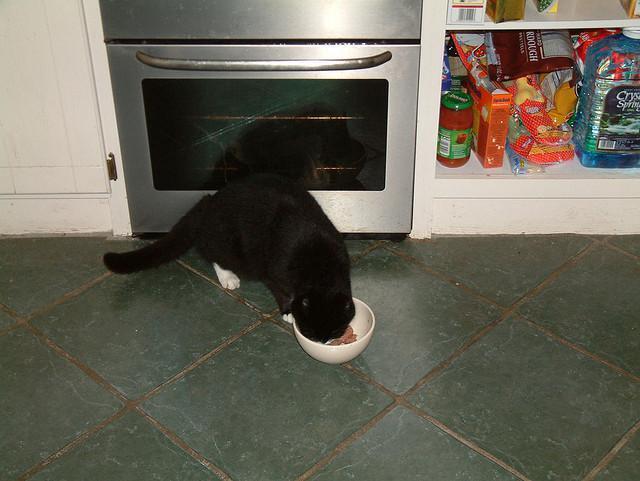How many bottles are there?
Give a very brief answer. 2. 